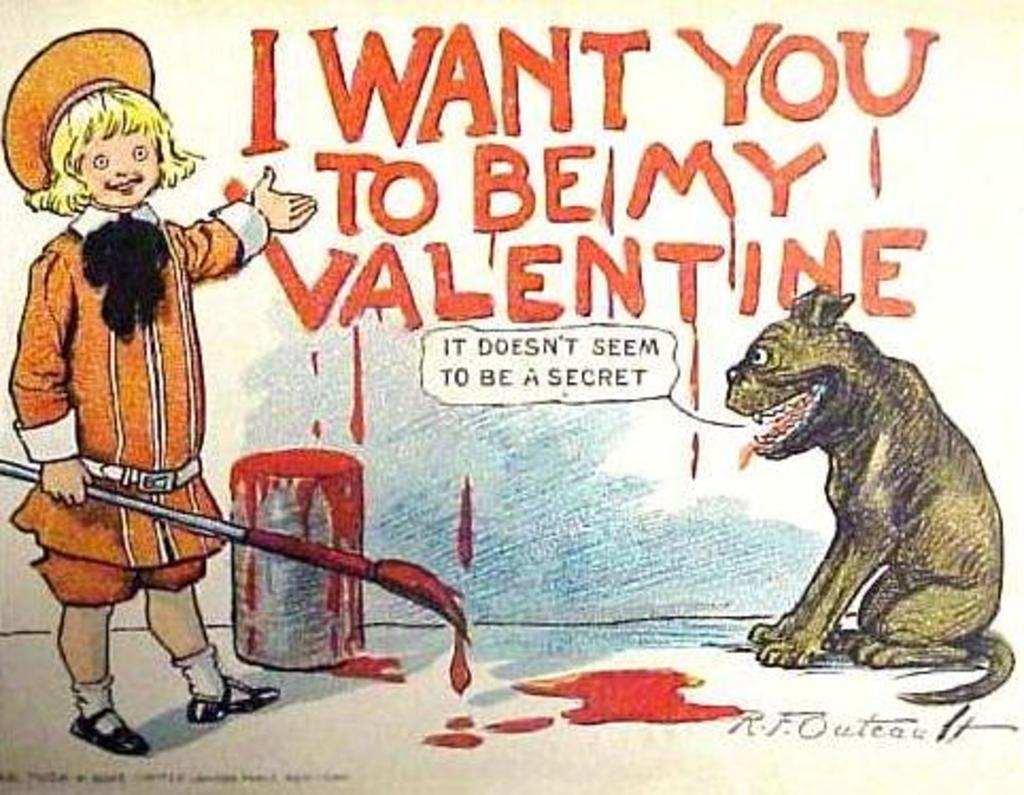What is depicted on the poster in the image? The poster contains a dog and a person holding a brush. Where is the poster located in the image? The poster is in the image, but its exact location is not specified. What can be seen in the background of the image? There is a wall in the background of the image, and there is text on the wall. What type of cord is attached to the dog's collar in the image? There is no cord attached to the dog's collar in the image, as the dog is depicted on a poster. 